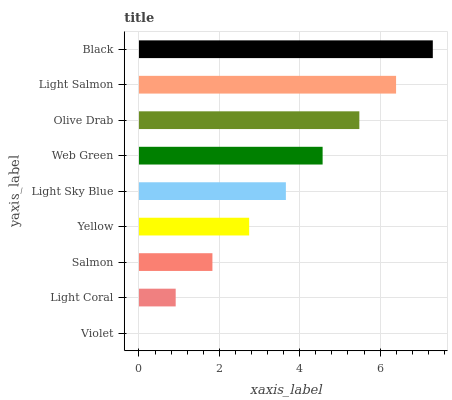Is Violet the minimum?
Answer yes or no. Yes. Is Black the maximum?
Answer yes or no. Yes. Is Light Coral the minimum?
Answer yes or no. No. Is Light Coral the maximum?
Answer yes or no. No. Is Light Coral greater than Violet?
Answer yes or no. Yes. Is Violet less than Light Coral?
Answer yes or no. Yes. Is Violet greater than Light Coral?
Answer yes or no. No. Is Light Coral less than Violet?
Answer yes or no. No. Is Light Sky Blue the high median?
Answer yes or no. Yes. Is Light Sky Blue the low median?
Answer yes or no. Yes. Is Black the high median?
Answer yes or no. No. Is Olive Drab the low median?
Answer yes or no. No. 